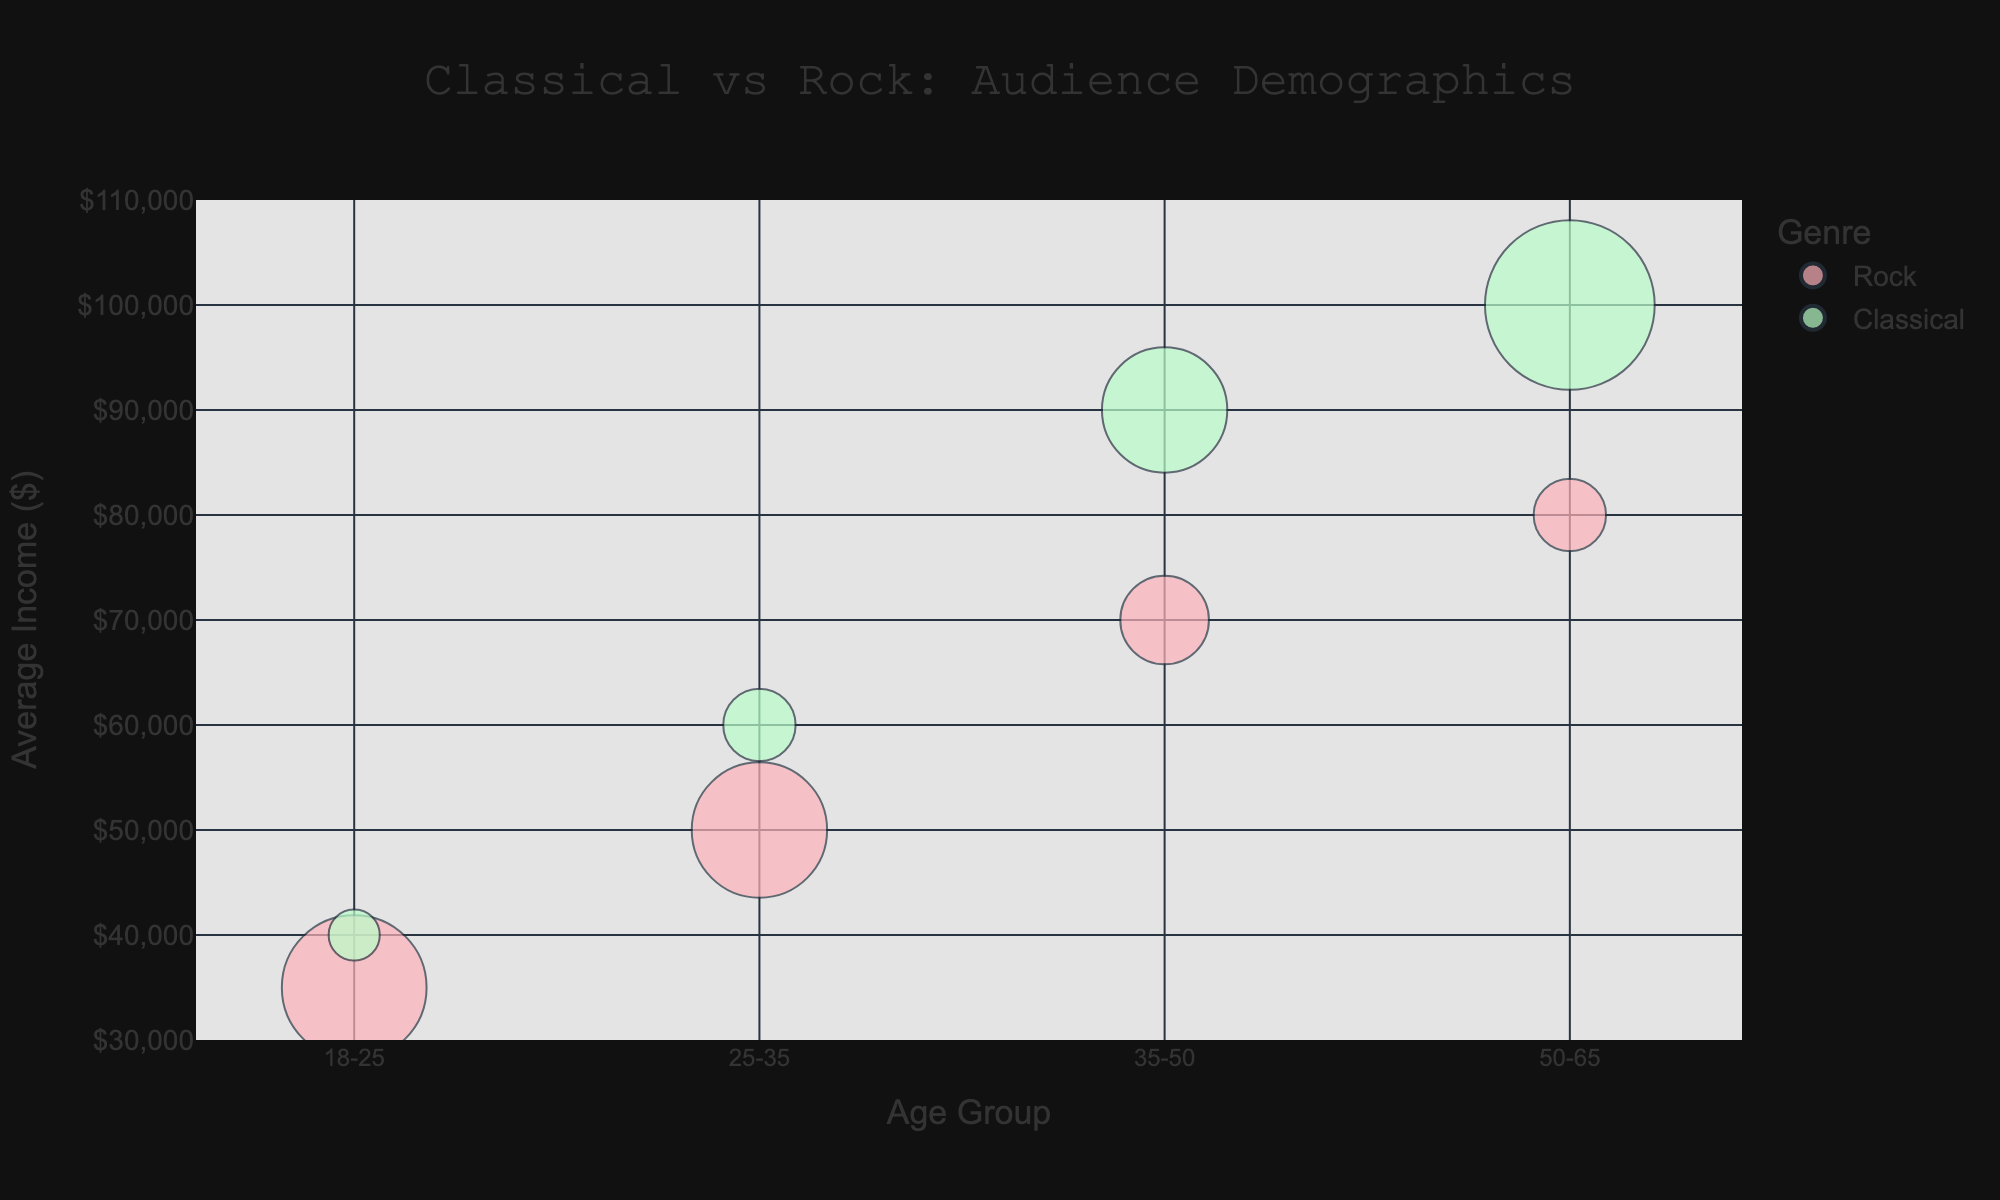what is the age group with the highest average income in the rock genre? Within the rock genre, the bubble for the 50-65 age group is the highest along the y-axis representing average income, indicating that this group has the highest average income.
Answer: 50-65 which genre has more popular concerts among the 35-50 age group? By looking at the size of the bubbles for both genres in the 35-50 age group, the bubble representing Classical concerts is larger than the one for Rock concerts, indicating Classical is more popular.
Answer: Classical what is the average ticket price for the 18-25 age group in Classical concerts? By examining the hover text information in the figure for the 18-25 age group in the Classical genre, the average ticket price is displayed.
Answer: $40 how does the popularity of concerts in the 18-25 age group compare between Classical and Rock? The size of the bubbles represents popularity. By comparing the 18-25 age groups, the Rock bubble is much larger than the Classical bubble, indicating Rock is more popular.
Answer: Rock is more popular what is the relationship between average income and popularity for the 50-65 age group in Classical concerts? Look at the 50-65 age group in Classical. The bubble's large size indicates high popularity, which correlates with the high average income shown by its position on the y-axis.
Answer: High popularity, high income which age group has the lowest average ticket price in Rock concerts? By examining the hover text for each age group within Rock concerts, the 18-25 age group shows the lowest price at $60 among Rock concerts.
Answer: 18-25 how does the average income differ between the youngest and oldest age groups for Classical concerts? The youngest age group in Classical (18-25) has an average income of $40,000, while the oldest (50-65) has $100,000. The difference is $100,000 - $40,000.
Answer: $60,000 in terms of ticket prices, compare the 25-35 age group between Classical and Rock genres. Refer to the hover text for both genres in the 25-35 age group. Classical shows an average ticket price of $60, while Rock shows $80, indicating Rock is more expensive.
Answer: Rock is $20 more which genre appears more popular among Senior Professionals? For the occupation "Senior Professionals," look at the 50-65 age group. The size of the Classical bubble is much larger than the Rock bubble, indicating greater popularity in Classical.
Answer: Classical what is the combined percentage popularity of concerts in the 35-50 age group across both genres? Look at the bubble sizes for the 35-50 age group in both genres. Classical is 30%, Rock is 15%. Adding these gives 30 + 15.
Answer: 45% 